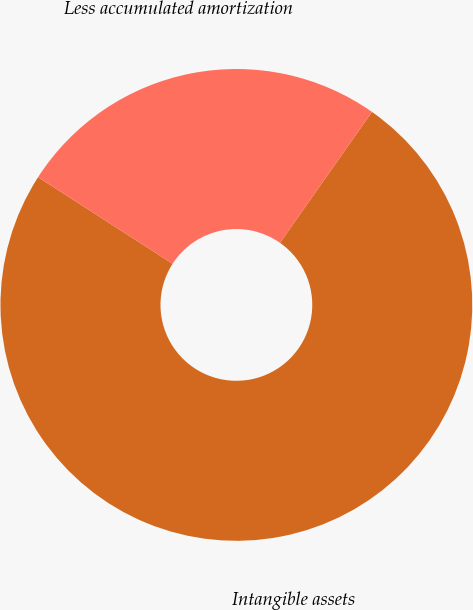<chart> <loc_0><loc_0><loc_500><loc_500><pie_chart><fcel>Intangible assets<fcel>Less accumulated amortization<nl><fcel>74.36%<fcel>25.64%<nl></chart> 